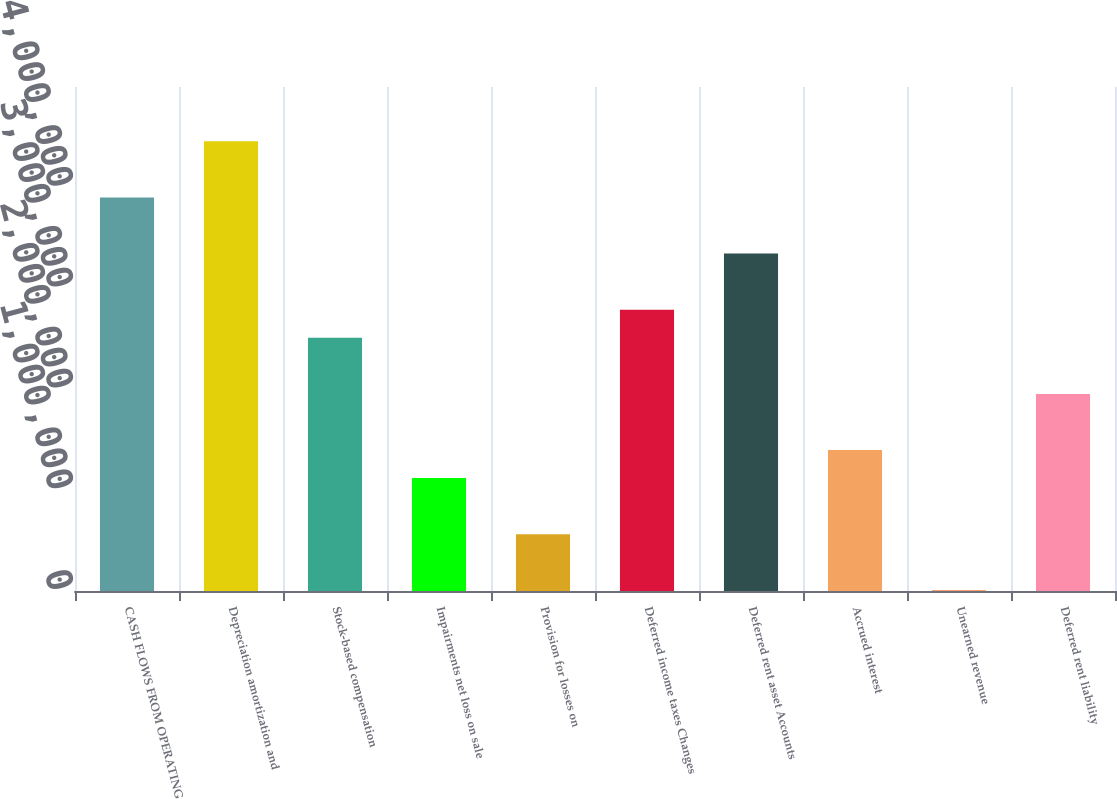Convert chart. <chart><loc_0><loc_0><loc_500><loc_500><bar_chart><fcel>CASH FLOWS FROM OPERATING<fcel>Depreciation amortization and<fcel>Stock-based compensation<fcel>Impairments net loss on sale<fcel>Provision for losses on<fcel>Deferred income taxes Changes<fcel>Deferred rent asset Accounts<fcel>Accrued interest<fcel>Unearned revenue<fcel>Deferred rent liability<nl><fcel>3.9046e+06<fcel>4.46149e+06<fcel>2.51237e+06<fcel>1.12014e+06<fcel>563243<fcel>2.79081e+06<fcel>3.3477e+06<fcel>1.39858e+06<fcel>6351<fcel>1.95547e+06<nl></chart> 